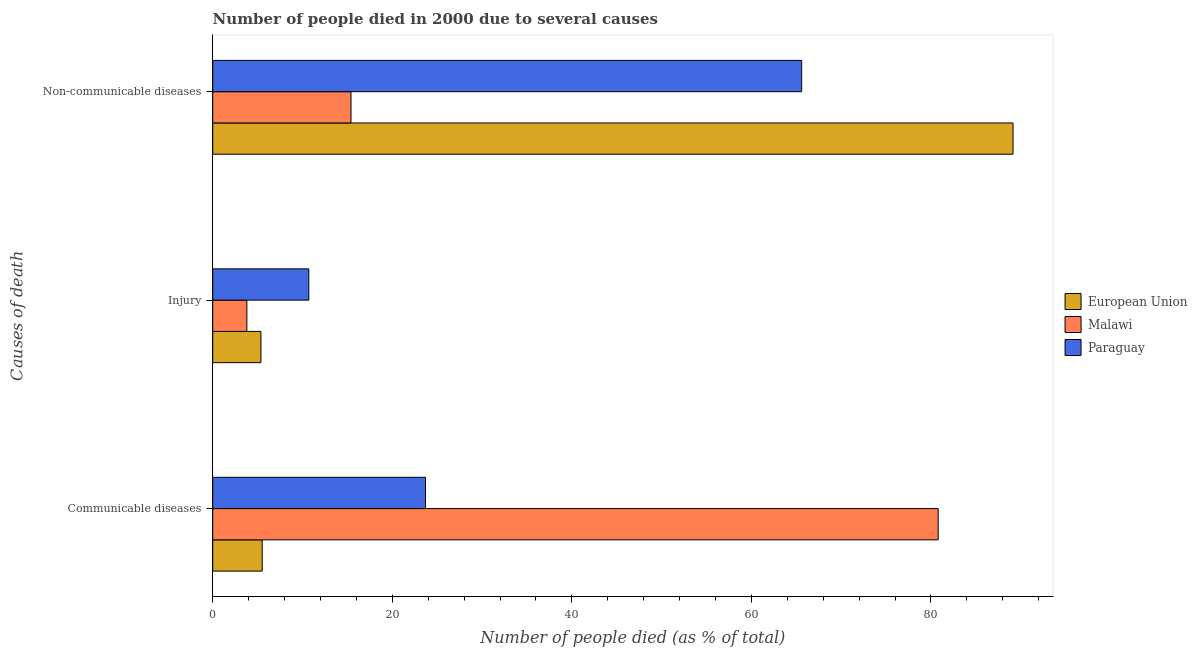How many different coloured bars are there?
Give a very brief answer. 3. How many groups of bars are there?
Your answer should be compact. 3. What is the label of the 3rd group of bars from the top?
Your answer should be very brief. Communicable diseases. What is the number of people who dies of non-communicable diseases in European Union?
Offer a very short reply. 89.14. Across all countries, what is the maximum number of people who dies of non-communicable diseases?
Provide a succinct answer. 89.14. Across all countries, what is the minimum number of people who died of injury?
Your response must be concise. 3.8. In which country was the number of people who died of injury maximum?
Keep it short and to the point. Paraguay. In which country was the number of people who dies of non-communicable diseases minimum?
Offer a very short reply. Malawi. What is the total number of people who died of injury in the graph?
Your answer should be compact. 19.87. What is the difference between the number of people who died of injury in Malawi and that in Paraguay?
Your answer should be very brief. -6.9. What is the difference between the number of people who died of injury in Malawi and the number of people who died of communicable diseases in European Union?
Your answer should be very brief. -1.71. What is the average number of people who died of communicable diseases per country?
Provide a succinct answer. 36.67. What is the difference between the number of people who dies of non-communicable diseases and number of people who died of injury in Paraguay?
Give a very brief answer. 54.9. In how many countries, is the number of people who dies of non-communicable diseases greater than 32 %?
Offer a terse response. 2. What is the ratio of the number of people who died of communicable diseases in Malawi to that in European Union?
Offer a very short reply. 14.67. Is the difference between the number of people who died of communicable diseases in Malawi and Paraguay greater than the difference between the number of people who died of injury in Malawi and Paraguay?
Make the answer very short. Yes. What is the difference between the highest and the second highest number of people who dies of non-communicable diseases?
Your response must be concise. 23.54. What is the difference between the highest and the lowest number of people who died of communicable diseases?
Your answer should be compact. 75.29. What does the 3rd bar from the bottom in Injury represents?
Your answer should be compact. Paraguay. Is it the case that in every country, the sum of the number of people who died of communicable diseases and number of people who died of injury is greater than the number of people who dies of non-communicable diseases?
Make the answer very short. No. How many bars are there?
Make the answer very short. 9. Are all the bars in the graph horizontal?
Give a very brief answer. Yes. Are the values on the major ticks of X-axis written in scientific E-notation?
Offer a very short reply. No. Does the graph contain any zero values?
Provide a short and direct response. No. Where does the legend appear in the graph?
Make the answer very short. Center right. How are the legend labels stacked?
Make the answer very short. Vertical. What is the title of the graph?
Offer a terse response. Number of people died in 2000 due to several causes. What is the label or title of the X-axis?
Your answer should be compact. Number of people died (as % of total). What is the label or title of the Y-axis?
Your answer should be compact. Causes of death. What is the Number of people died (as % of total) in European Union in Communicable diseases?
Give a very brief answer. 5.51. What is the Number of people died (as % of total) in Malawi in Communicable diseases?
Your answer should be very brief. 80.8. What is the Number of people died (as % of total) of Paraguay in Communicable diseases?
Your answer should be compact. 23.7. What is the Number of people died (as % of total) of European Union in Injury?
Provide a short and direct response. 5.37. What is the Number of people died (as % of total) in Malawi in Injury?
Your response must be concise. 3.8. What is the Number of people died (as % of total) in Paraguay in Injury?
Offer a very short reply. 10.7. What is the Number of people died (as % of total) of European Union in Non-communicable diseases?
Your response must be concise. 89.14. What is the Number of people died (as % of total) of Malawi in Non-communicable diseases?
Offer a terse response. 15.4. What is the Number of people died (as % of total) of Paraguay in Non-communicable diseases?
Make the answer very short. 65.6. Across all Causes of death, what is the maximum Number of people died (as % of total) of European Union?
Your answer should be very brief. 89.14. Across all Causes of death, what is the maximum Number of people died (as % of total) of Malawi?
Your answer should be compact. 80.8. Across all Causes of death, what is the maximum Number of people died (as % of total) in Paraguay?
Make the answer very short. 65.6. Across all Causes of death, what is the minimum Number of people died (as % of total) in European Union?
Your answer should be compact. 5.37. What is the total Number of people died (as % of total) in European Union in the graph?
Offer a terse response. 100.02. What is the difference between the Number of people died (as % of total) in European Union in Communicable diseases and that in Injury?
Keep it short and to the point. 0.14. What is the difference between the Number of people died (as % of total) in Paraguay in Communicable diseases and that in Injury?
Offer a very short reply. 13. What is the difference between the Number of people died (as % of total) in European Union in Communicable diseases and that in Non-communicable diseases?
Offer a very short reply. -83.63. What is the difference between the Number of people died (as % of total) of Malawi in Communicable diseases and that in Non-communicable diseases?
Your answer should be compact. 65.4. What is the difference between the Number of people died (as % of total) of Paraguay in Communicable diseases and that in Non-communicable diseases?
Offer a very short reply. -41.9. What is the difference between the Number of people died (as % of total) in European Union in Injury and that in Non-communicable diseases?
Your response must be concise. -83.77. What is the difference between the Number of people died (as % of total) in Malawi in Injury and that in Non-communicable diseases?
Offer a terse response. -11.6. What is the difference between the Number of people died (as % of total) of Paraguay in Injury and that in Non-communicable diseases?
Ensure brevity in your answer.  -54.9. What is the difference between the Number of people died (as % of total) of European Union in Communicable diseases and the Number of people died (as % of total) of Malawi in Injury?
Your answer should be compact. 1.71. What is the difference between the Number of people died (as % of total) of European Union in Communicable diseases and the Number of people died (as % of total) of Paraguay in Injury?
Your answer should be compact. -5.19. What is the difference between the Number of people died (as % of total) in Malawi in Communicable diseases and the Number of people died (as % of total) in Paraguay in Injury?
Offer a terse response. 70.1. What is the difference between the Number of people died (as % of total) in European Union in Communicable diseases and the Number of people died (as % of total) in Malawi in Non-communicable diseases?
Your answer should be compact. -9.89. What is the difference between the Number of people died (as % of total) of European Union in Communicable diseases and the Number of people died (as % of total) of Paraguay in Non-communicable diseases?
Give a very brief answer. -60.09. What is the difference between the Number of people died (as % of total) in Malawi in Communicable diseases and the Number of people died (as % of total) in Paraguay in Non-communicable diseases?
Your answer should be compact. 15.2. What is the difference between the Number of people died (as % of total) of European Union in Injury and the Number of people died (as % of total) of Malawi in Non-communicable diseases?
Your answer should be very brief. -10.03. What is the difference between the Number of people died (as % of total) of European Union in Injury and the Number of people died (as % of total) of Paraguay in Non-communicable diseases?
Offer a terse response. -60.23. What is the difference between the Number of people died (as % of total) in Malawi in Injury and the Number of people died (as % of total) in Paraguay in Non-communicable diseases?
Make the answer very short. -61.8. What is the average Number of people died (as % of total) in European Union per Causes of death?
Ensure brevity in your answer.  33.34. What is the average Number of people died (as % of total) of Malawi per Causes of death?
Your answer should be compact. 33.33. What is the average Number of people died (as % of total) in Paraguay per Causes of death?
Provide a succinct answer. 33.33. What is the difference between the Number of people died (as % of total) of European Union and Number of people died (as % of total) of Malawi in Communicable diseases?
Offer a very short reply. -75.29. What is the difference between the Number of people died (as % of total) of European Union and Number of people died (as % of total) of Paraguay in Communicable diseases?
Offer a terse response. -18.19. What is the difference between the Number of people died (as % of total) in Malawi and Number of people died (as % of total) in Paraguay in Communicable diseases?
Provide a succinct answer. 57.1. What is the difference between the Number of people died (as % of total) in European Union and Number of people died (as % of total) in Malawi in Injury?
Offer a very short reply. 1.57. What is the difference between the Number of people died (as % of total) in European Union and Number of people died (as % of total) in Paraguay in Injury?
Offer a very short reply. -5.33. What is the difference between the Number of people died (as % of total) of Malawi and Number of people died (as % of total) of Paraguay in Injury?
Offer a terse response. -6.9. What is the difference between the Number of people died (as % of total) of European Union and Number of people died (as % of total) of Malawi in Non-communicable diseases?
Provide a short and direct response. 73.74. What is the difference between the Number of people died (as % of total) of European Union and Number of people died (as % of total) of Paraguay in Non-communicable diseases?
Offer a terse response. 23.54. What is the difference between the Number of people died (as % of total) of Malawi and Number of people died (as % of total) of Paraguay in Non-communicable diseases?
Give a very brief answer. -50.2. What is the ratio of the Number of people died (as % of total) of European Union in Communicable diseases to that in Injury?
Your answer should be compact. 1.03. What is the ratio of the Number of people died (as % of total) of Malawi in Communicable diseases to that in Injury?
Give a very brief answer. 21.26. What is the ratio of the Number of people died (as % of total) of Paraguay in Communicable diseases to that in Injury?
Offer a terse response. 2.21. What is the ratio of the Number of people died (as % of total) of European Union in Communicable diseases to that in Non-communicable diseases?
Your answer should be very brief. 0.06. What is the ratio of the Number of people died (as % of total) in Malawi in Communicable diseases to that in Non-communicable diseases?
Ensure brevity in your answer.  5.25. What is the ratio of the Number of people died (as % of total) in Paraguay in Communicable diseases to that in Non-communicable diseases?
Provide a succinct answer. 0.36. What is the ratio of the Number of people died (as % of total) in European Union in Injury to that in Non-communicable diseases?
Provide a succinct answer. 0.06. What is the ratio of the Number of people died (as % of total) in Malawi in Injury to that in Non-communicable diseases?
Keep it short and to the point. 0.25. What is the ratio of the Number of people died (as % of total) of Paraguay in Injury to that in Non-communicable diseases?
Your response must be concise. 0.16. What is the difference between the highest and the second highest Number of people died (as % of total) of European Union?
Keep it short and to the point. 83.63. What is the difference between the highest and the second highest Number of people died (as % of total) of Malawi?
Keep it short and to the point. 65.4. What is the difference between the highest and the second highest Number of people died (as % of total) of Paraguay?
Your answer should be very brief. 41.9. What is the difference between the highest and the lowest Number of people died (as % of total) of European Union?
Make the answer very short. 83.77. What is the difference between the highest and the lowest Number of people died (as % of total) in Malawi?
Keep it short and to the point. 77. What is the difference between the highest and the lowest Number of people died (as % of total) of Paraguay?
Your response must be concise. 54.9. 